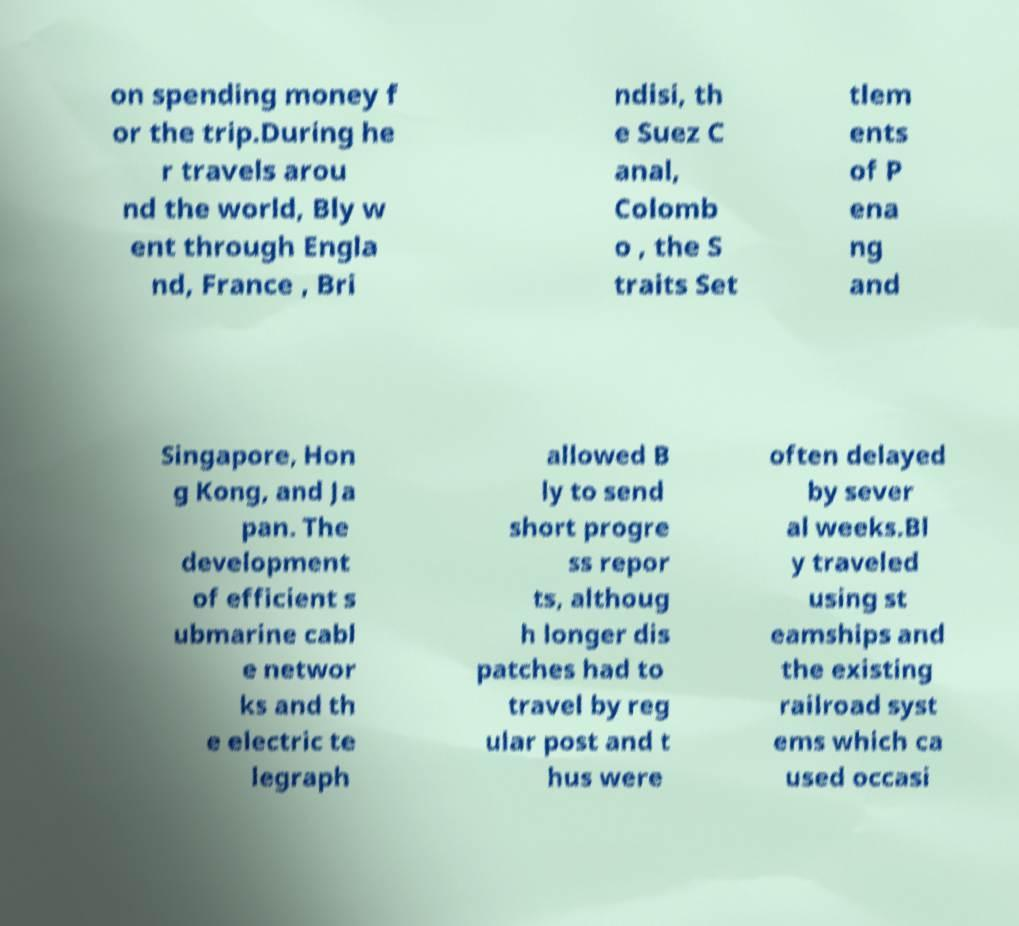I need the written content from this picture converted into text. Can you do that? on spending money f or the trip.During he r travels arou nd the world, Bly w ent through Engla nd, France , Bri ndisi, th e Suez C anal, Colomb o , the S traits Set tlem ents of P ena ng and Singapore, Hon g Kong, and Ja pan. The development of efficient s ubmarine cabl e networ ks and th e electric te legraph allowed B ly to send short progre ss repor ts, althoug h longer dis patches had to travel by reg ular post and t hus were often delayed by sever al weeks.Bl y traveled using st eamships and the existing railroad syst ems which ca used occasi 